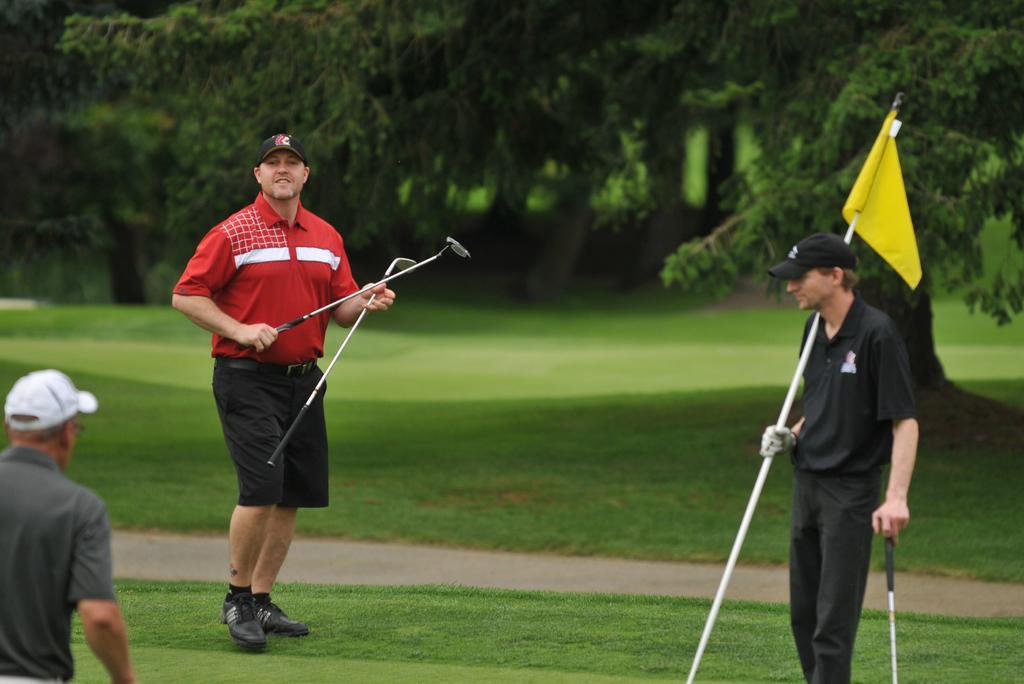How would you summarize this image in a sentence or two? In this image there are persons standing and holding stick in their hands. In the background there are plants and there is grass on the ground and on the right side there is a person standing and holding a flag in his hand which is yellow in colour. 